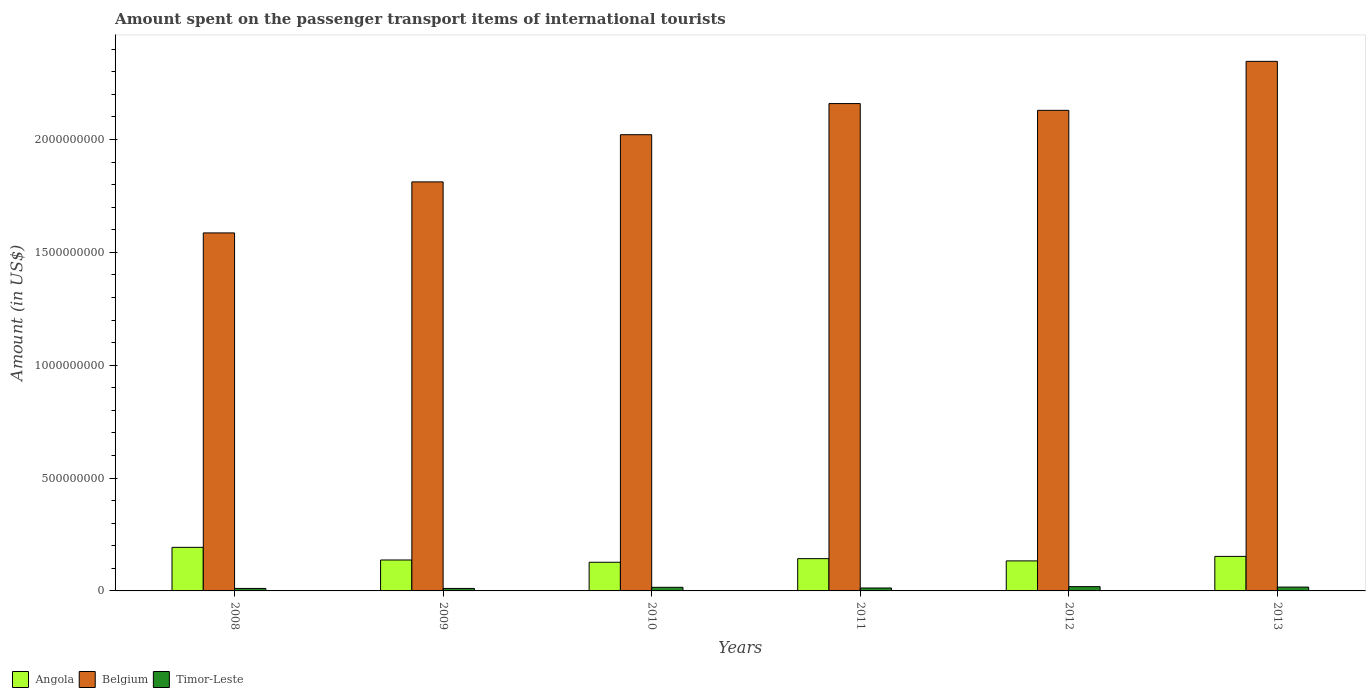How many different coloured bars are there?
Give a very brief answer. 3. Are the number of bars on each tick of the X-axis equal?
Give a very brief answer. Yes. How many bars are there on the 2nd tick from the right?
Provide a short and direct response. 3. What is the label of the 1st group of bars from the left?
Give a very brief answer. 2008. What is the amount spent on the passenger transport items of international tourists in Belgium in 2012?
Your answer should be compact. 2.13e+09. Across all years, what is the maximum amount spent on the passenger transport items of international tourists in Belgium?
Your answer should be compact. 2.35e+09. Across all years, what is the minimum amount spent on the passenger transport items of international tourists in Belgium?
Your response must be concise. 1.59e+09. In which year was the amount spent on the passenger transport items of international tourists in Angola minimum?
Your answer should be compact. 2010. What is the total amount spent on the passenger transport items of international tourists in Angola in the graph?
Offer a terse response. 8.86e+08. What is the difference between the amount spent on the passenger transport items of international tourists in Angola in 2010 and that in 2013?
Provide a short and direct response. -2.60e+07. What is the difference between the amount spent on the passenger transport items of international tourists in Timor-Leste in 2008 and the amount spent on the passenger transport items of international tourists in Belgium in 2012?
Offer a very short reply. -2.12e+09. What is the average amount spent on the passenger transport items of international tourists in Belgium per year?
Provide a succinct answer. 2.01e+09. In the year 2009, what is the difference between the amount spent on the passenger transport items of international tourists in Belgium and amount spent on the passenger transport items of international tourists in Timor-Leste?
Ensure brevity in your answer.  1.80e+09. In how many years, is the amount spent on the passenger transport items of international tourists in Belgium greater than 200000000 US$?
Provide a succinct answer. 6. What is the ratio of the amount spent on the passenger transport items of international tourists in Belgium in 2008 to that in 2012?
Offer a terse response. 0.74. Is the amount spent on the passenger transport items of international tourists in Angola in 2008 less than that in 2012?
Your response must be concise. No. Is the difference between the amount spent on the passenger transport items of international tourists in Belgium in 2009 and 2012 greater than the difference between the amount spent on the passenger transport items of international tourists in Timor-Leste in 2009 and 2012?
Make the answer very short. No. What is the difference between the highest and the second highest amount spent on the passenger transport items of international tourists in Belgium?
Give a very brief answer. 1.87e+08. What is the difference between the highest and the lowest amount spent on the passenger transport items of international tourists in Angola?
Give a very brief answer. 6.60e+07. In how many years, is the amount spent on the passenger transport items of international tourists in Angola greater than the average amount spent on the passenger transport items of international tourists in Angola taken over all years?
Offer a very short reply. 2. What does the 2nd bar from the left in 2010 represents?
Your answer should be very brief. Belgium. What does the 2nd bar from the right in 2010 represents?
Provide a succinct answer. Belgium. Is it the case that in every year, the sum of the amount spent on the passenger transport items of international tourists in Belgium and amount spent on the passenger transport items of international tourists in Timor-Leste is greater than the amount spent on the passenger transport items of international tourists in Angola?
Offer a very short reply. Yes. How many bars are there?
Offer a terse response. 18. Are the values on the major ticks of Y-axis written in scientific E-notation?
Your answer should be compact. No. Does the graph contain any zero values?
Give a very brief answer. No. Does the graph contain grids?
Ensure brevity in your answer.  No. Where does the legend appear in the graph?
Your answer should be compact. Bottom left. How many legend labels are there?
Your answer should be compact. 3. What is the title of the graph?
Provide a succinct answer. Amount spent on the passenger transport items of international tourists. Does "Burkina Faso" appear as one of the legend labels in the graph?
Provide a short and direct response. No. What is the Amount (in US$) of Angola in 2008?
Your response must be concise. 1.93e+08. What is the Amount (in US$) of Belgium in 2008?
Ensure brevity in your answer.  1.59e+09. What is the Amount (in US$) in Timor-Leste in 2008?
Give a very brief answer. 1.10e+07. What is the Amount (in US$) of Angola in 2009?
Your response must be concise. 1.37e+08. What is the Amount (in US$) in Belgium in 2009?
Offer a very short reply. 1.81e+09. What is the Amount (in US$) of Timor-Leste in 2009?
Make the answer very short. 1.10e+07. What is the Amount (in US$) in Angola in 2010?
Provide a succinct answer. 1.27e+08. What is the Amount (in US$) of Belgium in 2010?
Ensure brevity in your answer.  2.02e+09. What is the Amount (in US$) in Timor-Leste in 2010?
Your answer should be very brief. 1.60e+07. What is the Amount (in US$) in Angola in 2011?
Offer a very short reply. 1.43e+08. What is the Amount (in US$) of Belgium in 2011?
Make the answer very short. 2.16e+09. What is the Amount (in US$) in Timor-Leste in 2011?
Offer a very short reply. 1.30e+07. What is the Amount (in US$) in Angola in 2012?
Offer a very short reply. 1.33e+08. What is the Amount (in US$) in Belgium in 2012?
Your answer should be very brief. 2.13e+09. What is the Amount (in US$) in Timor-Leste in 2012?
Your answer should be very brief. 1.90e+07. What is the Amount (in US$) of Angola in 2013?
Give a very brief answer. 1.53e+08. What is the Amount (in US$) of Belgium in 2013?
Make the answer very short. 2.35e+09. What is the Amount (in US$) of Timor-Leste in 2013?
Your answer should be very brief. 1.70e+07. Across all years, what is the maximum Amount (in US$) of Angola?
Offer a terse response. 1.93e+08. Across all years, what is the maximum Amount (in US$) in Belgium?
Ensure brevity in your answer.  2.35e+09. Across all years, what is the maximum Amount (in US$) of Timor-Leste?
Keep it short and to the point. 1.90e+07. Across all years, what is the minimum Amount (in US$) in Angola?
Your answer should be very brief. 1.27e+08. Across all years, what is the minimum Amount (in US$) in Belgium?
Provide a short and direct response. 1.59e+09. Across all years, what is the minimum Amount (in US$) of Timor-Leste?
Offer a very short reply. 1.10e+07. What is the total Amount (in US$) of Angola in the graph?
Your answer should be very brief. 8.86e+08. What is the total Amount (in US$) of Belgium in the graph?
Give a very brief answer. 1.21e+1. What is the total Amount (in US$) in Timor-Leste in the graph?
Provide a succinct answer. 8.70e+07. What is the difference between the Amount (in US$) of Angola in 2008 and that in 2009?
Ensure brevity in your answer.  5.60e+07. What is the difference between the Amount (in US$) of Belgium in 2008 and that in 2009?
Ensure brevity in your answer.  -2.26e+08. What is the difference between the Amount (in US$) in Timor-Leste in 2008 and that in 2009?
Ensure brevity in your answer.  0. What is the difference between the Amount (in US$) in Angola in 2008 and that in 2010?
Your answer should be very brief. 6.60e+07. What is the difference between the Amount (in US$) in Belgium in 2008 and that in 2010?
Offer a very short reply. -4.35e+08. What is the difference between the Amount (in US$) of Timor-Leste in 2008 and that in 2010?
Keep it short and to the point. -5.00e+06. What is the difference between the Amount (in US$) of Belgium in 2008 and that in 2011?
Keep it short and to the point. -5.73e+08. What is the difference between the Amount (in US$) of Angola in 2008 and that in 2012?
Make the answer very short. 6.00e+07. What is the difference between the Amount (in US$) of Belgium in 2008 and that in 2012?
Make the answer very short. -5.43e+08. What is the difference between the Amount (in US$) of Timor-Leste in 2008 and that in 2012?
Your response must be concise. -8.00e+06. What is the difference between the Amount (in US$) in Angola in 2008 and that in 2013?
Your response must be concise. 4.00e+07. What is the difference between the Amount (in US$) in Belgium in 2008 and that in 2013?
Make the answer very short. -7.60e+08. What is the difference between the Amount (in US$) in Timor-Leste in 2008 and that in 2013?
Your response must be concise. -6.00e+06. What is the difference between the Amount (in US$) in Angola in 2009 and that in 2010?
Keep it short and to the point. 1.00e+07. What is the difference between the Amount (in US$) in Belgium in 2009 and that in 2010?
Offer a very short reply. -2.09e+08. What is the difference between the Amount (in US$) of Timor-Leste in 2009 and that in 2010?
Provide a succinct answer. -5.00e+06. What is the difference between the Amount (in US$) of Angola in 2009 and that in 2011?
Offer a terse response. -6.00e+06. What is the difference between the Amount (in US$) in Belgium in 2009 and that in 2011?
Provide a short and direct response. -3.47e+08. What is the difference between the Amount (in US$) of Angola in 2009 and that in 2012?
Offer a very short reply. 4.00e+06. What is the difference between the Amount (in US$) of Belgium in 2009 and that in 2012?
Ensure brevity in your answer.  -3.17e+08. What is the difference between the Amount (in US$) of Timor-Leste in 2009 and that in 2012?
Keep it short and to the point. -8.00e+06. What is the difference between the Amount (in US$) in Angola in 2009 and that in 2013?
Provide a short and direct response. -1.60e+07. What is the difference between the Amount (in US$) in Belgium in 2009 and that in 2013?
Ensure brevity in your answer.  -5.34e+08. What is the difference between the Amount (in US$) of Timor-Leste in 2009 and that in 2013?
Offer a very short reply. -6.00e+06. What is the difference between the Amount (in US$) of Angola in 2010 and that in 2011?
Make the answer very short. -1.60e+07. What is the difference between the Amount (in US$) in Belgium in 2010 and that in 2011?
Provide a short and direct response. -1.38e+08. What is the difference between the Amount (in US$) of Timor-Leste in 2010 and that in 2011?
Provide a short and direct response. 3.00e+06. What is the difference between the Amount (in US$) in Angola in 2010 and that in 2012?
Ensure brevity in your answer.  -6.00e+06. What is the difference between the Amount (in US$) in Belgium in 2010 and that in 2012?
Give a very brief answer. -1.08e+08. What is the difference between the Amount (in US$) of Angola in 2010 and that in 2013?
Make the answer very short. -2.60e+07. What is the difference between the Amount (in US$) of Belgium in 2010 and that in 2013?
Your answer should be compact. -3.25e+08. What is the difference between the Amount (in US$) of Angola in 2011 and that in 2012?
Keep it short and to the point. 1.00e+07. What is the difference between the Amount (in US$) of Belgium in 2011 and that in 2012?
Offer a very short reply. 3.00e+07. What is the difference between the Amount (in US$) in Timor-Leste in 2011 and that in 2012?
Your response must be concise. -6.00e+06. What is the difference between the Amount (in US$) in Angola in 2011 and that in 2013?
Give a very brief answer. -1.00e+07. What is the difference between the Amount (in US$) in Belgium in 2011 and that in 2013?
Provide a short and direct response. -1.87e+08. What is the difference between the Amount (in US$) in Timor-Leste in 2011 and that in 2013?
Your answer should be compact. -4.00e+06. What is the difference between the Amount (in US$) in Angola in 2012 and that in 2013?
Keep it short and to the point. -2.00e+07. What is the difference between the Amount (in US$) of Belgium in 2012 and that in 2013?
Offer a very short reply. -2.17e+08. What is the difference between the Amount (in US$) in Timor-Leste in 2012 and that in 2013?
Offer a terse response. 2.00e+06. What is the difference between the Amount (in US$) of Angola in 2008 and the Amount (in US$) of Belgium in 2009?
Offer a terse response. -1.62e+09. What is the difference between the Amount (in US$) in Angola in 2008 and the Amount (in US$) in Timor-Leste in 2009?
Your answer should be compact. 1.82e+08. What is the difference between the Amount (in US$) in Belgium in 2008 and the Amount (in US$) in Timor-Leste in 2009?
Your answer should be compact. 1.58e+09. What is the difference between the Amount (in US$) in Angola in 2008 and the Amount (in US$) in Belgium in 2010?
Your response must be concise. -1.83e+09. What is the difference between the Amount (in US$) of Angola in 2008 and the Amount (in US$) of Timor-Leste in 2010?
Offer a terse response. 1.77e+08. What is the difference between the Amount (in US$) of Belgium in 2008 and the Amount (in US$) of Timor-Leste in 2010?
Offer a very short reply. 1.57e+09. What is the difference between the Amount (in US$) in Angola in 2008 and the Amount (in US$) in Belgium in 2011?
Offer a terse response. -1.97e+09. What is the difference between the Amount (in US$) in Angola in 2008 and the Amount (in US$) in Timor-Leste in 2011?
Your answer should be very brief. 1.80e+08. What is the difference between the Amount (in US$) in Belgium in 2008 and the Amount (in US$) in Timor-Leste in 2011?
Your answer should be very brief. 1.57e+09. What is the difference between the Amount (in US$) in Angola in 2008 and the Amount (in US$) in Belgium in 2012?
Your answer should be very brief. -1.94e+09. What is the difference between the Amount (in US$) in Angola in 2008 and the Amount (in US$) in Timor-Leste in 2012?
Your response must be concise. 1.74e+08. What is the difference between the Amount (in US$) in Belgium in 2008 and the Amount (in US$) in Timor-Leste in 2012?
Give a very brief answer. 1.57e+09. What is the difference between the Amount (in US$) of Angola in 2008 and the Amount (in US$) of Belgium in 2013?
Make the answer very short. -2.15e+09. What is the difference between the Amount (in US$) in Angola in 2008 and the Amount (in US$) in Timor-Leste in 2013?
Make the answer very short. 1.76e+08. What is the difference between the Amount (in US$) of Belgium in 2008 and the Amount (in US$) of Timor-Leste in 2013?
Offer a very short reply. 1.57e+09. What is the difference between the Amount (in US$) of Angola in 2009 and the Amount (in US$) of Belgium in 2010?
Provide a succinct answer. -1.88e+09. What is the difference between the Amount (in US$) in Angola in 2009 and the Amount (in US$) in Timor-Leste in 2010?
Give a very brief answer. 1.21e+08. What is the difference between the Amount (in US$) in Belgium in 2009 and the Amount (in US$) in Timor-Leste in 2010?
Your answer should be compact. 1.80e+09. What is the difference between the Amount (in US$) of Angola in 2009 and the Amount (in US$) of Belgium in 2011?
Your answer should be compact. -2.02e+09. What is the difference between the Amount (in US$) of Angola in 2009 and the Amount (in US$) of Timor-Leste in 2011?
Offer a terse response. 1.24e+08. What is the difference between the Amount (in US$) in Belgium in 2009 and the Amount (in US$) in Timor-Leste in 2011?
Provide a succinct answer. 1.80e+09. What is the difference between the Amount (in US$) in Angola in 2009 and the Amount (in US$) in Belgium in 2012?
Provide a short and direct response. -1.99e+09. What is the difference between the Amount (in US$) in Angola in 2009 and the Amount (in US$) in Timor-Leste in 2012?
Keep it short and to the point. 1.18e+08. What is the difference between the Amount (in US$) of Belgium in 2009 and the Amount (in US$) of Timor-Leste in 2012?
Your answer should be very brief. 1.79e+09. What is the difference between the Amount (in US$) of Angola in 2009 and the Amount (in US$) of Belgium in 2013?
Make the answer very short. -2.21e+09. What is the difference between the Amount (in US$) of Angola in 2009 and the Amount (in US$) of Timor-Leste in 2013?
Offer a terse response. 1.20e+08. What is the difference between the Amount (in US$) in Belgium in 2009 and the Amount (in US$) in Timor-Leste in 2013?
Your response must be concise. 1.80e+09. What is the difference between the Amount (in US$) of Angola in 2010 and the Amount (in US$) of Belgium in 2011?
Give a very brief answer. -2.03e+09. What is the difference between the Amount (in US$) in Angola in 2010 and the Amount (in US$) in Timor-Leste in 2011?
Your answer should be very brief. 1.14e+08. What is the difference between the Amount (in US$) in Belgium in 2010 and the Amount (in US$) in Timor-Leste in 2011?
Provide a succinct answer. 2.01e+09. What is the difference between the Amount (in US$) in Angola in 2010 and the Amount (in US$) in Belgium in 2012?
Provide a succinct answer. -2.00e+09. What is the difference between the Amount (in US$) in Angola in 2010 and the Amount (in US$) in Timor-Leste in 2012?
Provide a succinct answer. 1.08e+08. What is the difference between the Amount (in US$) in Belgium in 2010 and the Amount (in US$) in Timor-Leste in 2012?
Give a very brief answer. 2.00e+09. What is the difference between the Amount (in US$) of Angola in 2010 and the Amount (in US$) of Belgium in 2013?
Your answer should be very brief. -2.22e+09. What is the difference between the Amount (in US$) in Angola in 2010 and the Amount (in US$) in Timor-Leste in 2013?
Provide a short and direct response. 1.10e+08. What is the difference between the Amount (in US$) of Belgium in 2010 and the Amount (in US$) of Timor-Leste in 2013?
Your answer should be compact. 2.00e+09. What is the difference between the Amount (in US$) in Angola in 2011 and the Amount (in US$) in Belgium in 2012?
Keep it short and to the point. -1.99e+09. What is the difference between the Amount (in US$) of Angola in 2011 and the Amount (in US$) of Timor-Leste in 2012?
Your answer should be very brief. 1.24e+08. What is the difference between the Amount (in US$) in Belgium in 2011 and the Amount (in US$) in Timor-Leste in 2012?
Make the answer very short. 2.14e+09. What is the difference between the Amount (in US$) in Angola in 2011 and the Amount (in US$) in Belgium in 2013?
Offer a terse response. -2.20e+09. What is the difference between the Amount (in US$) of Angola in 2011 and the Amount (in US$) of Timor-Leste in 2013?
Your response must be concise. 1.26e+08. What is the difference between the Amount (in US$) of Belgium in 2011 and the Amount (in US$) of Timor-Leste in 2013?
Offer a terse response. 2.14e+09. What is the difference between the Amount (in US$) of Angola in 2012 and the Amount (in US$) of Belgium in 2013?
Your answer should be compact. -2.21e+09. What is the difference between the Amount (in US$) of Angola in 2012 and the Amount (in US$) of Timor-Leste in 2013?
Make the answer very short. 1.16e+08. What is the difference between the Amount (in US$) of Belgium in 2012 and the Amount (in US$) of Timor-Leste in 2013?
Make the answer very short. 2.11e+09. What is the average Amount (in US$) in Angola per year?
Offer a very short reply. 1.48e+08. What is the average Amount (in US$) of Belgium per year?
Provide a succinct answer. 2.01e+09. What is the average Amount (in US$) in Timor-Leste per year?
Provide a short and direct response. 1.45e+07. In the year 2008, what is the difference between the Amount (in US$) in Angola and Amount (in US$) in Belgium?
Provide a short and direct response. -1.39e+09. In the year 2008, what is the difference between the Amount (in US$) in Angola and Amount (in US$) in Timor-Leste?
Give a very brief answer. 1.82e+08. In the year 2008, what is the difference between the Amount (in US$) of Belgium and Amount (in US$) of Timor-Leste?
Your response must be concise. 1.58e+09. In the year 2009, what is the difference between the Amount (in US$) in Angola and Amount (in US$) in Belgium?
Give a very brief answer. -1.68e+09. In the year 2009, what is the difference between the Amount (in US$) in Angola and Amount (in US$) in Timor-Leste?
Give a very brief answer. 1.26e+08. In the year 2009, what is the difference between the Amount (in US$) of Belgium and Amount (in US$) of Timor-Leste?
Keep it short and to the point. 1.80e+09. In the year 2010, what is the difference between the Amount (in US$) in Angola and Amount (in US$) in Belgium?
Offer a very short reply. -1.89e+09. In the year 2010, what is the difference between the Amount (in US$) in Angola and Amount (in US$) in Timor-Leste?
Offer a terse response. 1.11e+08. In the year 2010, what is the difference between the Amount (in US$) of Belgium and Amount (in US$) of Timor-Leste?
Offer a terse response. 2.00e+09. In the year 2011, what is the difference between the Amount (in US$) of Angola and Amount (in US$) of Belgium?
Make the answer very short. -2.02e+09. In the year 2011, what is the difference between the Amount (in US$) of Angola and Amount (in US$) of Timor-Leste?
Offer a very short reply. 1.30e+08. In the year 2011, what is the difference between the Amount (in US$) of Belgium and Amount (in US$) of Timor-Leste?
Give a very brief answer. 2.15e+09. In the year 2012, what is the difference between the Amount (in US$) in Angola and Amount (in US$) in Belgium?
Provide a succinct answer. -2.00e+09. In the year 2012, what is the difference between the Amount (in US$) of Angola and Amount (in US$) of Timor-Leste?
Offer a terse response. 1.14e+08. In the year 2012, what is the difference between the Amount (in US$) of Belgium and Amount (in US$) of Timor-Leste?
Provide a succinct answer. 2.11e+09. In the year 2013, what is the difference between the Amount (in US$) in Angola and Amount (in US$) in Belgium?
Provide a short and direct response. -2.19e+09. In the year 2013, what is the difference between the Amount (in US$) in Angola and Amount (in US$) in Timor-Leste?
Ensure brevity in your answer.  1.36e+08. In the year 2013, what is the difference between the Amount (in US$) in Belgium and Amount (in US$) in Timor-Leste?
Offer a very short reply. 2.33e+09. What is the ratio of the Amount (in US$) of Angola in 2008 to that in 2009?
Keep it short and to the point. 1.41. What is the ratio of the Amount (in US$) of Belgium in 2008 to that in 2009?
Offer a very short reply. 0.88. What is the ratio of the Amount (in US$) of Angola in 2008 to that in 2010?
Your response must be concise. 1.52. What is the ratio of the Amount (in US$) of Belgium in 2008 to that in 2010?
Your response must be concise. 0.78. What is the ratio of the Amount (in US$) of Timor-Leste in 2008 to that in 2010?
Give a very brief answer. 0.69. What is the ratio of the Amount (in US$) in Angola in 2008 to that in 2011?
Provide a short and direct response. 1.35. What is the ratio of the Amount (in US$) in Belgium in 2008 to that in 2011?
Offer a terse response. 0.73. What is the ratio of the Amount (in US$) of Timor-Leste in 2008 to that in 2011?
Your answer should be very brief. 0.85. What is the ratio of the Amount (in US$) of Angola in 2008 to that in 2012?
Provide a short and direct response. 1.45. What is the ratio of the Amount (in US$) in Belgium in 2008 to that in 2012?
Offer a very short reply. 0.74. What is the ratio of the Amount (in US$) of Timor-Leste in 2008 to that in 2012?
Ensure brevity in your answer.  0.58. What is the ratio of the Amount (in US$) in Angola in 2008 to that in 2013?
Provide a short and direct response. 1.26. What is the ratio of the Amount (in US$) in Belgium in 2008 to that in 2013?
Offer a very short reply. 0.68. What is the ratio of the Amount (in US$) of Timor-Leste in 2008 to that in 2013?
Your response must be concise. 0.65. What is the ratio of the Amount (in US$) of Angola in 2009 to that in 2010?
Your answer should be compact. 1.08. What is the ratio of the Amount (in US$) of Belgium in 2009 to that in 2010?
Ensure brevity in your answer.  0.9. What is the ratio of the Amount (in US$) in Timor-Leste in 2009 to that in 2010?
Provide a succinct answer. 0.69. What is the ratio of the Amount (in US$) of Angola in 2009 to that in 2011?
Your answer should be compact. 0.96. What is the ratio of the Amount (in US$) in Belgium in 2009 to that in 2011?
Provide a succinct answer. 0.84. What is the ratio of the Amount (in US$) of Timor-Leste in 2009 to that in 2011?
Give a very brief answer. 0.85. What is the ratio of the Amount (in US$) in Angola in 2009 to that in 2012?
Offer a very short reply. 1.03. What is the ratio of the Amount (in US$) of Belgium in 2009 to that in 2012?
Give a very brief answer. 0.85. What is the ratio of the Amount (in US$) in Timor-Leste in 2009 to that in 2012?
Provide a succinct answer. 0.58. What is the ratio of the Amount (in US$) of Angola in 2009 to that in 2013?
Offer a very short reply. 0.9. What is the ratio of the Amount (in US$) of Belgium in 2009 to that in 2013?
Provide a succinct answer. 0.77. What is the ratio of the Amount (in US$) in Timor-Leste in 2009 to that in 2013?
Keep it short and to the point. 0.65. What is the ratio of the Amount (in US$) in Angola in 2010 to that in 2011?
Offer a very short reply. 0.89. What is the ratio of the Amount (in US$) in Belgium in 2010 to that in 2011?
Your answer should be compact. 0.94. What is the ratio of the Amount (in US$) in Timor-Leste in 2010 to that in 2011?
Provide a succinct answer. 1.23. What is the ratio of the Amount (in US$) of Angola in 2010 to that in 2012?
Your answer should be compact. 0.95. What is the ratio of the Amount (in US$) of Belgium in 2010 to that in 2012?
Offer a terse response. 0.95. What is the ratio of the Amount (in US$) in Timor-Leste in 2010 to that in 2012?
Provide a succinct answer. 0.84. What is the ratio of the Amount (in US$) in Angola in 2010 to that in 2013?
Provide a succinct answer. 0.83. What is the ratio of the Amount (in US$) in Belgium in 2010 to that in 2013?
Your answer should be compact. 0.86. What is the ratio of the Amount (in US$) in Timor-Leste in 2010 to that in 2013?
Keep it short and to the point. 0.94. What is the ratio of the Amount (in US$) of Angola in 2011 to that in 2012?
Your response must be concise. 1.08. What is the ratio of the Amount (in US$) in Belgium in 2011 to that in 2012?
Offer a very short reply. 1.01. What is the ratio of the Amount (in US$) of Timor-Leste in 2011 to that in 2012?
Offer a terse response. 0.68. What is the ratio of the Amount (in US$) in Angola in 2011 to that in 2013?
Provide a short and direct response. 0.93. What is the ratio of the Amount (in US$) of Belgium in 2011 to that in 2013?
Your response must be concise. 0.92. What is the ratio of the Amount (in US$) in Timor-Leste in 2011 to that in 2013?
Provide a short and direct response. 0.76. What is the ratio of the Amount (in US$) in Angola in 2012 to that in 2013?
Your response must be concise. 0.87. What is the ratio of the Amount (in US$) in Belgium in 2012 to that in 2013?
Give a very brief answer. 0.91. What is the ratio of the Amount (in US$) of Timor-Leste in 2012 to that in 2013?
Ensure brevity in your answer.  1.12. What is the difference between the highest and the second highest Amount (in US$) of Angola?
Give a very brief answer. 4.00e+07. What is the difference between the highest and the second highest Amount (in US$) of Belgium?
Offer a terse response. 1.87e+08. What is the difference between the highest and the second highest Amount (in US$) in Timor-Leste?
Your answer should be compact. 2.00e+06. What is the difference between the highest and the lowest Amount (in US$) of Angola?
Ensure brevity in your answer.  6.60e+07. What is the difference between the highest and the lowest Amount (in US$) of Belgium?
Your response must be concise. 7.60e+08. What is the difference between the highest and the lowest Amount (in US$) of Timor-Leste?
Provide a short and direct response. 8.00e+06. 